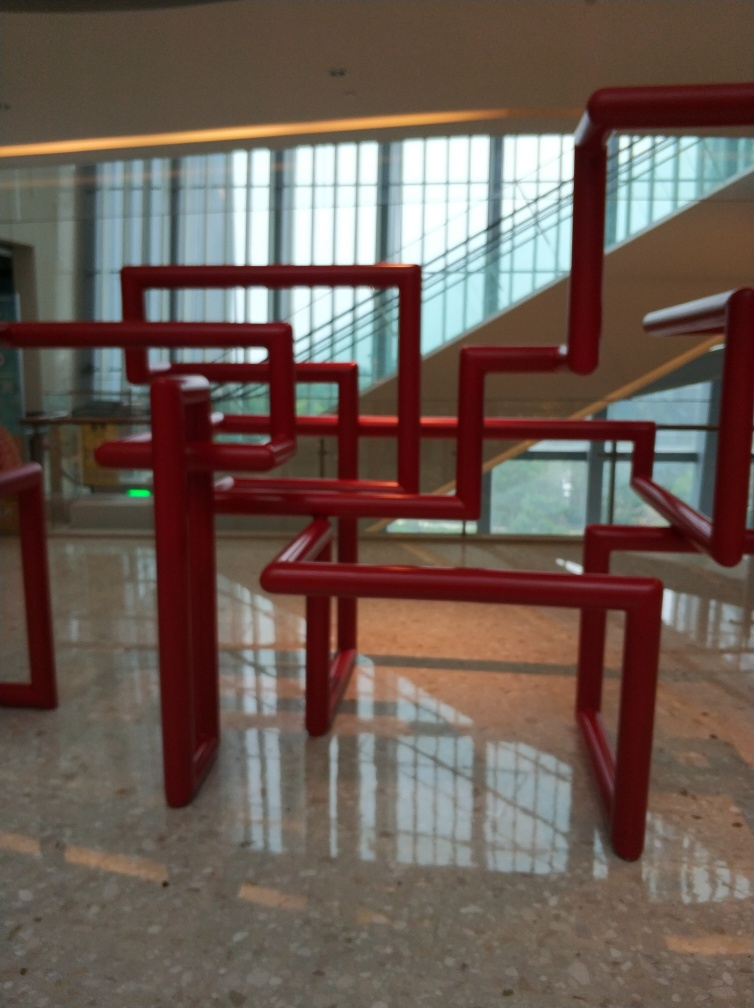Can you describe the style or inspiration behind the design of these structures? The bright red structures are reminiscent of modern abstract art, possibly inspired by minimalist or geometric styles. The lines and forms evoke a sense of organized chaos, suggesting a contemporary artistic influence. 